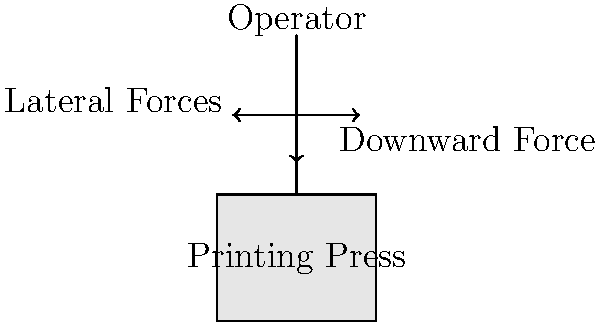In operating an early printing press, which biomechanical factor would likely contribute most significantly to physical stress on the operator's body over extended periods of use? To answer this question, we need to consider the biomechanical factors involved in operating an early printing press:

1. Posture: The operator would likely maintain a standing position for long periods, potentially leading to fatigue and strain on the lower back and legs.

2. Repetitive motion: The printing process involves repetitive movements, which can cause strain on joints and muscles, particularly in the arms and shoulders.

3. Force application: Significant force is required to press the type onto the paper, involving:
   a) Downward force: Applied through the arms and upper body
   b) Lateral forces: Applied to move the press mechanism

4. Weight bearing: The operator may need to lift and manipulate heavy type blocks and paper stacks.

5. Sustained muscle contraction: Holding the press in position requires isometric muscle contractions.

Among these factors, the repetitive motion combined with force application is likely to be the most significant contributor to physical stress over time. This is because:

1. It involves high-force movements repeated many times.
2. It affects multiple body parts (arms, shoulders, back).
3. It can lead to cumulative trauma disorders like tendinitis or carpal tunnel syndrome.
4. The force required doesn't decrease over time, unlike static postures where the body can adapt.

While all factors contribute to overall stress, the combination of repetition and force in the pressing motion is most likely to cause long-term biomechanical issues.
Answer: Repetitive high-force movements 